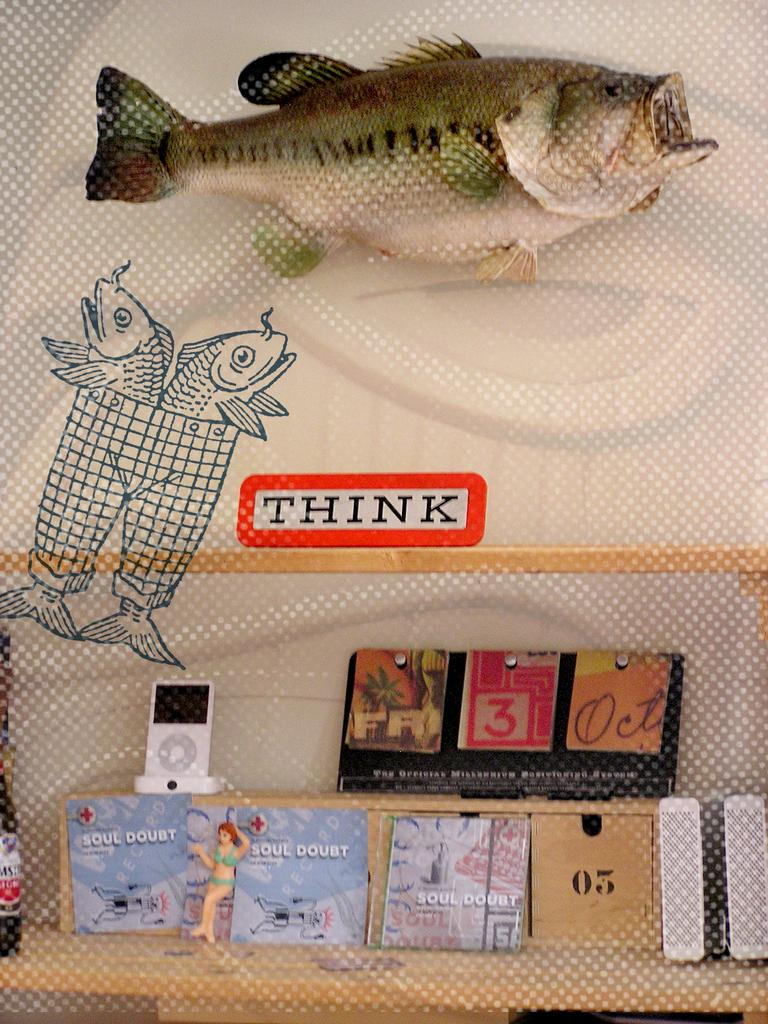What type of visual display is shown in the image? The image appears to be a poster. What kind of animals are depicted on the poster? There are images of fishes on the poster. What else can be seen on the poster besides the images of fishes? There is a board with text on it and a few objects present on the poster. What type of skirt is being worn by the men in the image? There are no men or skirts present in the image; it features images of fishes and other objects on a poster. What level of expertise is required to understand the content of the poster? The level of expertise required to understand the content of the poster cannot be determined from the image alone. 